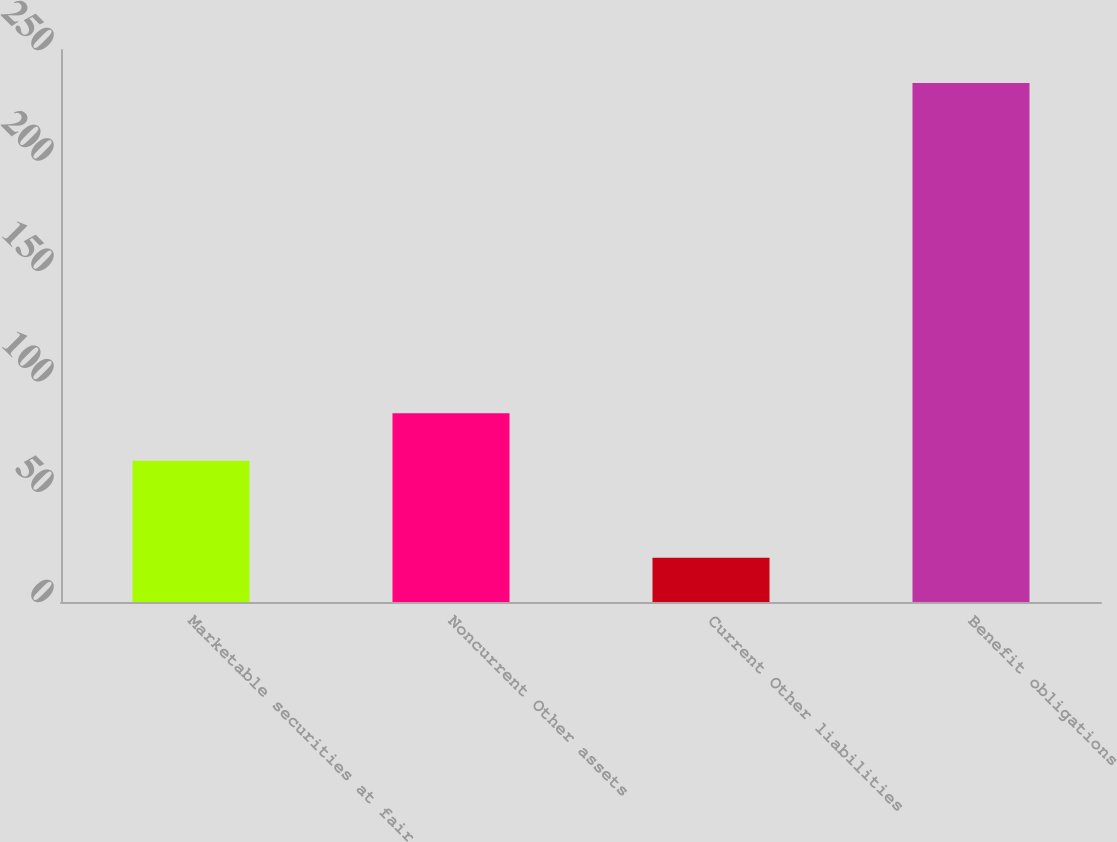<chart> <loc_0><loc_0><loc_500><loc_500><bar_chart><fcel>Marketable securities at fair<fcel>Noncurrent Other assets<fcel>Current Other liabilities<fcel>Benefit obligations<nl><fcel>64<fcel>85.5<fcel>20<fcel>235<nl></chart> 